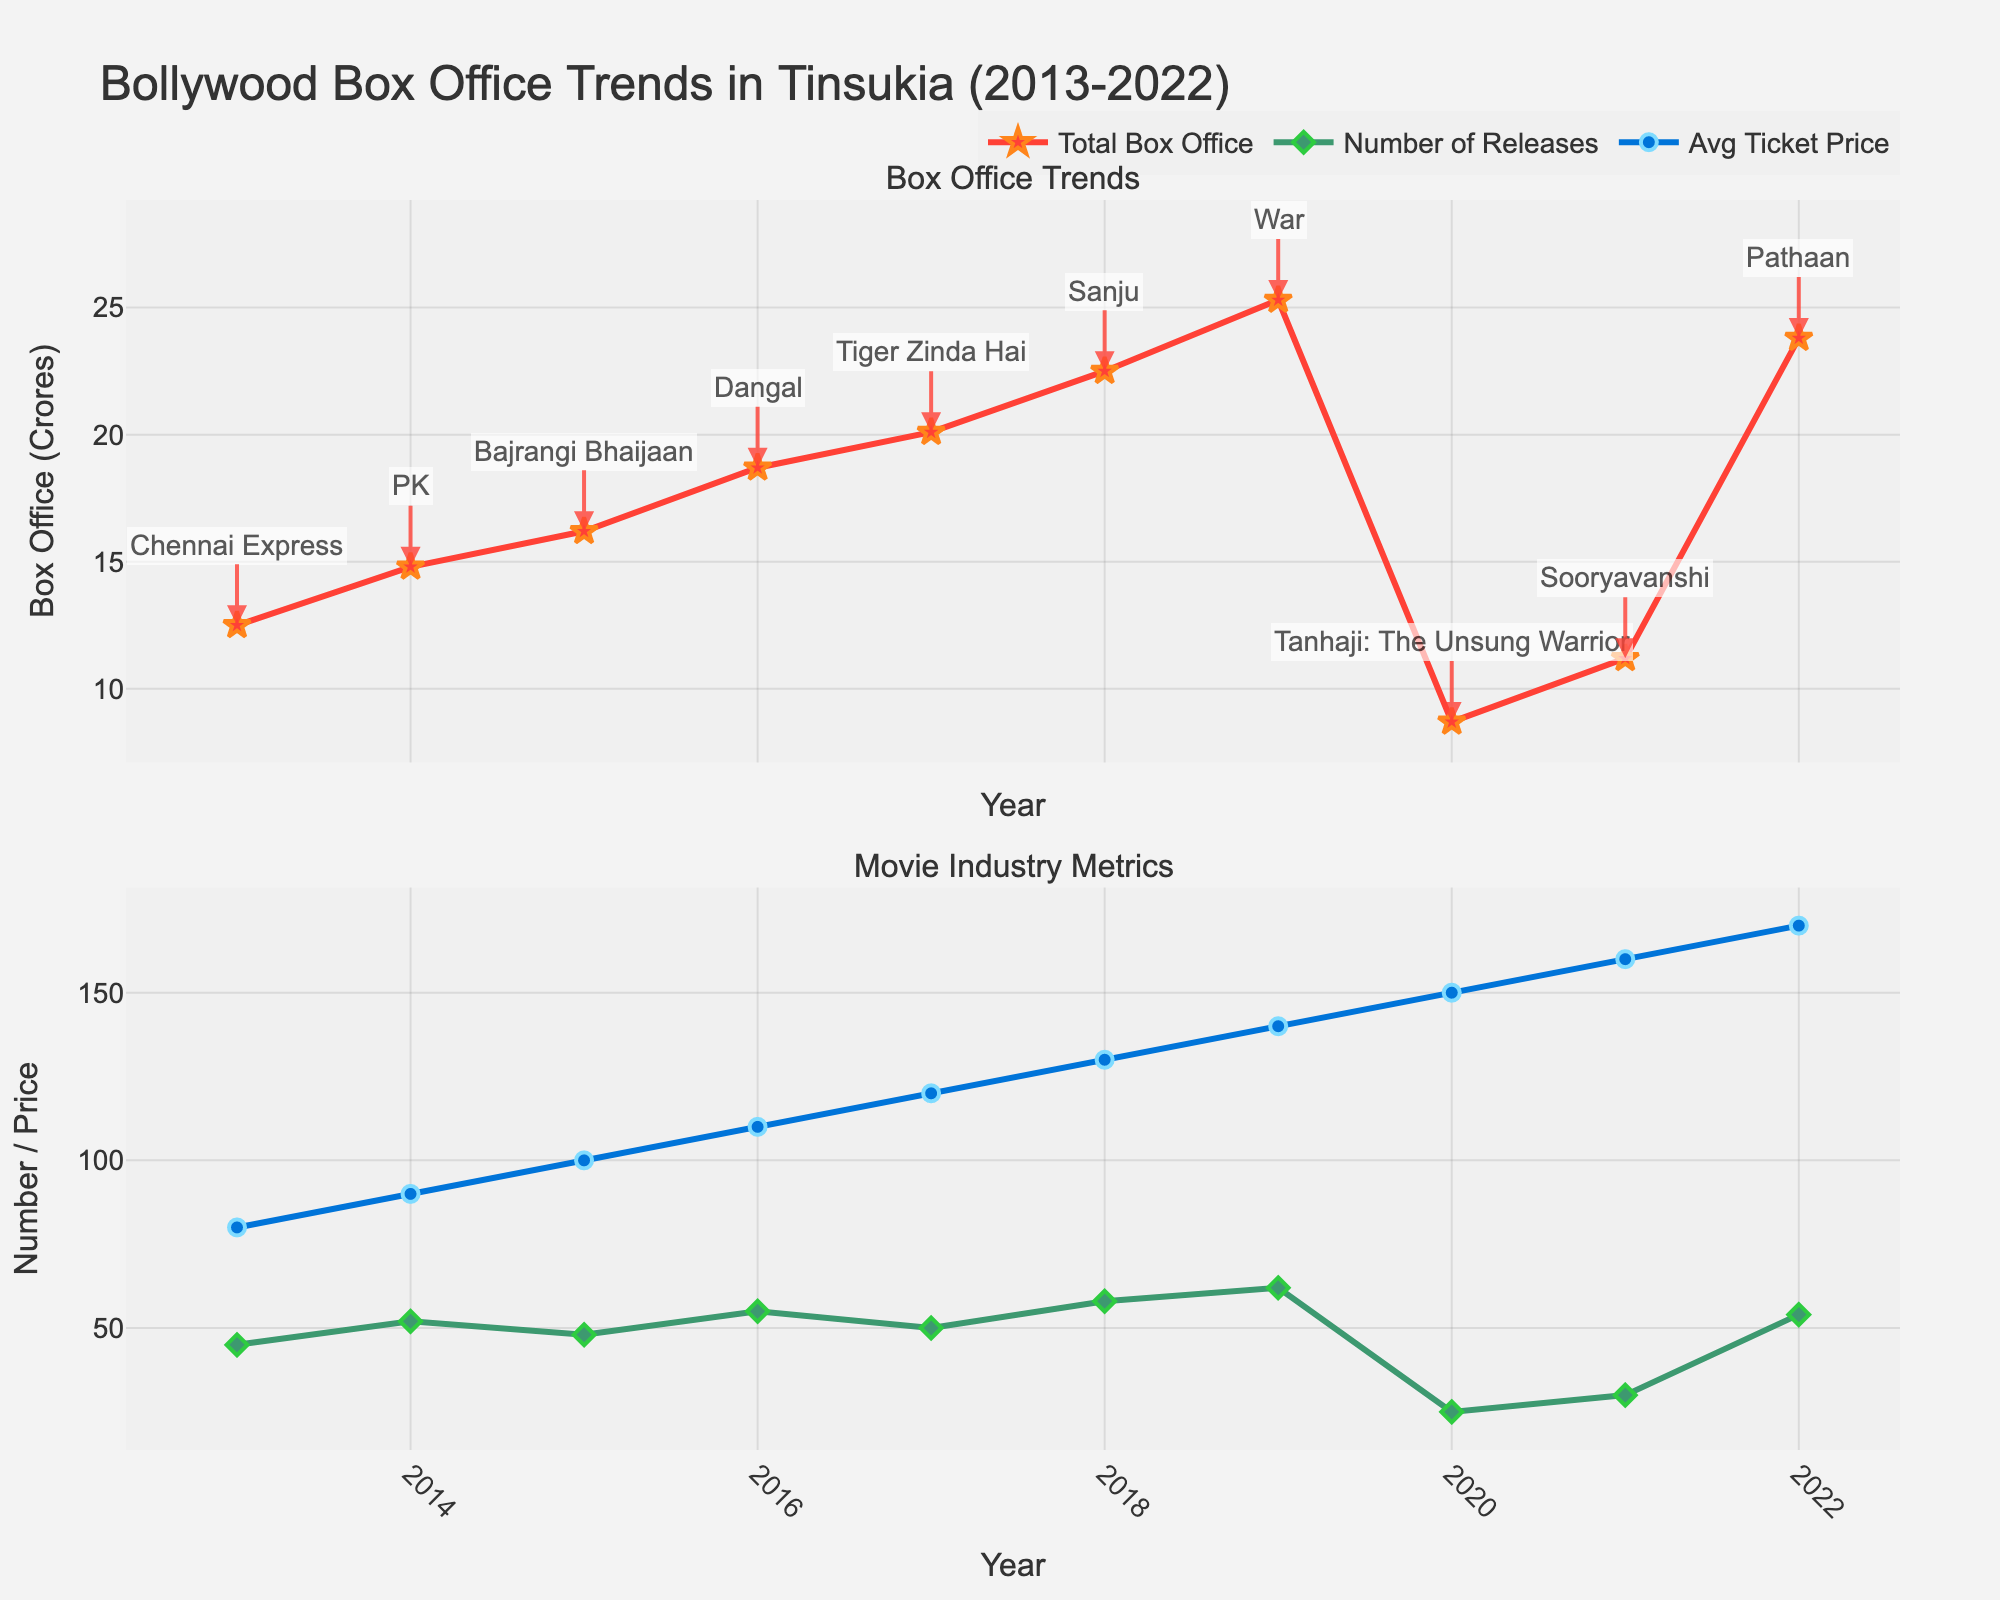Which year had the highest total box office collection? Looking at the top plot, the red line representing total box office peaks in 2022.
Answer: 2022 How did the number of movie releases in 2020 compare to 2019? By checking the green line in the bottom plot, the number of releases in 2020 was significantly lower than in 2019, with a drop from 62 to 25.
Answer: Less What is the trend in average ticket prices from 2013 to 2022? The blue line in the bottom plot shows an upward trend in average ticket prices through the years from 2013 to 2022.
Answer: Increasing Based on the figure, how did the total box office collection change between 2020 and 2021, and what might have contributed to this change? The total box office collection increased from 8.7 crores in 2020 to 11.2 crores in 2021. Given the context, the partial recovery might be attributed to the easing of COVID-19 restrictions.
Answer: Increased Which year had the lowest total box office collection, and what was the top-grossing movie that year? The year with the lowest total box office collection is 2020, and the top-grossing movie was "Tanhaji: The Unsung Warrior".
Answer: 2020, Tanhaji: The Unsung Warrior Compare the increase in the total box office collection between 2013 to 2017 and 2018 to 2022. The increase from 2013 (12.5 crores) to 2017 (20.1 crores) is 7.6 crores, while the increase from 2018 (22.5 crores) to 2022 (23.8 crores) is 1.3 crores. Therefore, the increase was greater in the first period.
Answer: Greater in 2013-2017 What's the average number of movie releases per year from 2013 to 2022? Adding up the number of releases each year (45, 52, 48, 55, 50, 58, 62, 25, 30, 54) gives a total of 479. Dividing this by 10 years gives the average.
Answer: 47.9 Which year saw the highest average ticket price, and how much was it? The highest average ticket price can be seen in the blue line, which peaks in 2022 at 170 Rs.
Answer: 2022, 170 Rs How did the total box office collection in 2015 compare to 2016? The total box office collection in 2016 (18.7 crores) was higher than in 2015 (16.2 crores).
Answer: Higher What was the total box office collection in 2017, and which movie contributed the most to it? The total box office collection in 2017 was 20.1 crores, and the top-grossing movie was "Tiger Zinda Hai".
Answer: 20.1 crores, Tiger Zinda Hai 